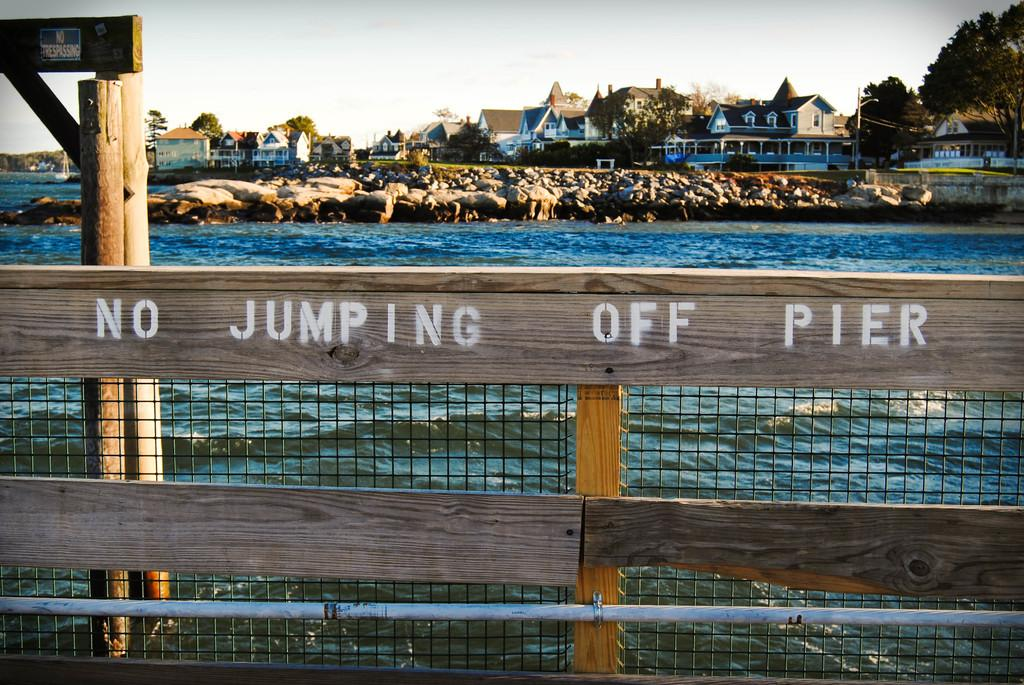What type of fencing is present in the image? There is a wooden fencing in the image. Where is the wooden fencing located in relation to the beach? The wooden fencing is in front of the beach. What else can be seen in the image besides the wooden fencing and beach? There are buildings visible in the image. What is visible at the top of the image? The sky is visible at the top of the image. What type of vegetation is present in the top right of the image? There are trees in the top right of the image. What is the caption of the image? There is no caption present in the image. How many crows are visible in the image? There are no crows present in the image. 